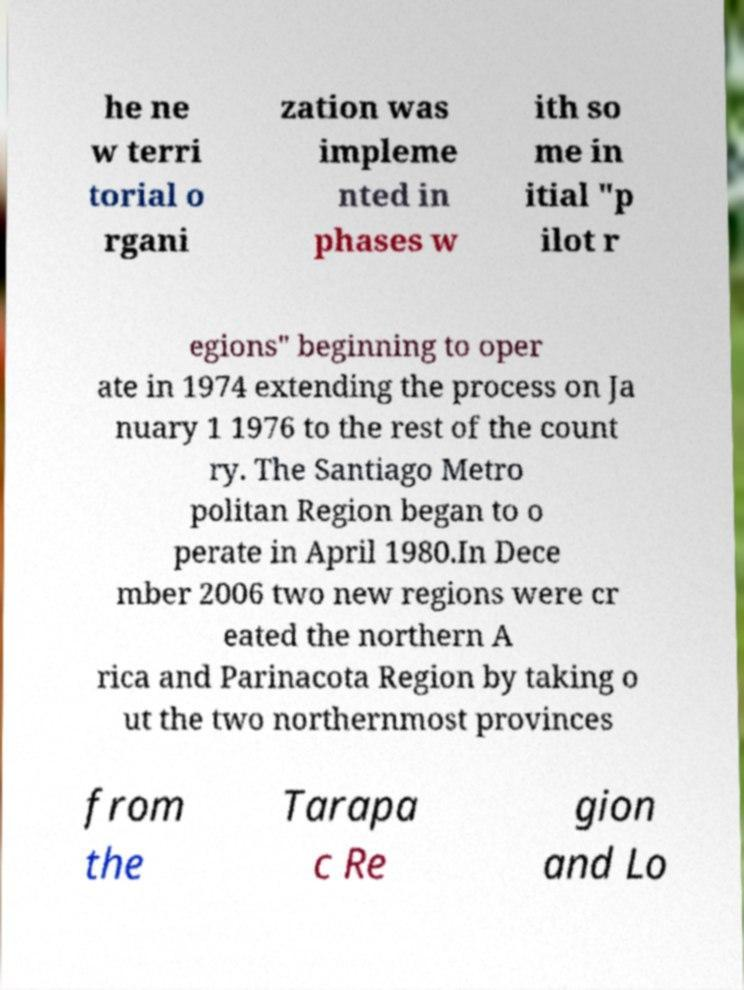For documentation purposes, I need the text within this image transcribed. Could you provide that? he ne w terri torial o rgani zation was impleme nted in phases w ith so me in itial "p ilot r egions" beginning to oper ate in 1974 extending the process on Ja nuary 1 1976 to the rest of the count ry. The Santiago Metro politan Region began to o perate in April 1980.In Dece mber 2006 two new regions were cr eated the northern A rica and Parinacota Region by taking o ut the two northernmost provinces from the Tarapa c Re gion and Lo 